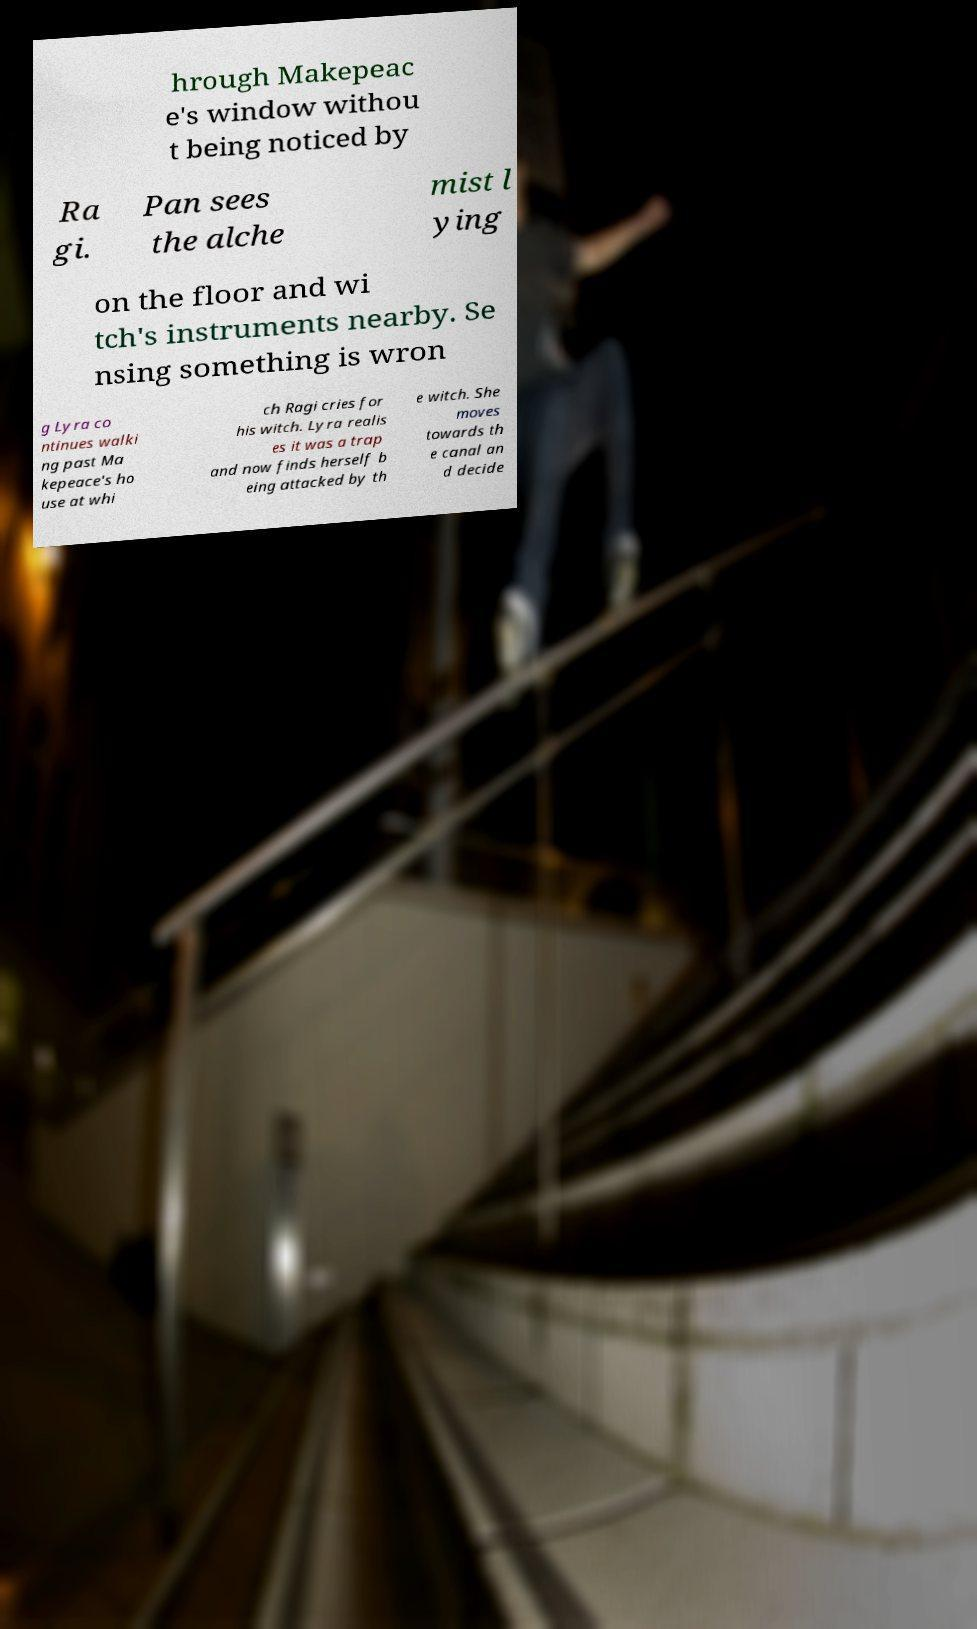There's text embedded in this image that I need extracted. Can you transcribe it verbatim? hrough Makepeac e's window withou t being noticed by Ra gi. Pan sees the alche mist l ying on the floor and wi tch's instruments nearby. Se nsing something is wron g Lyra co ntinues walki ng past Ma kepeace's ho use at whi ch Ragi cries for his witch. Lyra realis es it was a trap and now finds herself b eing attacked by th e witch. She moves towards th e canal an d decide 